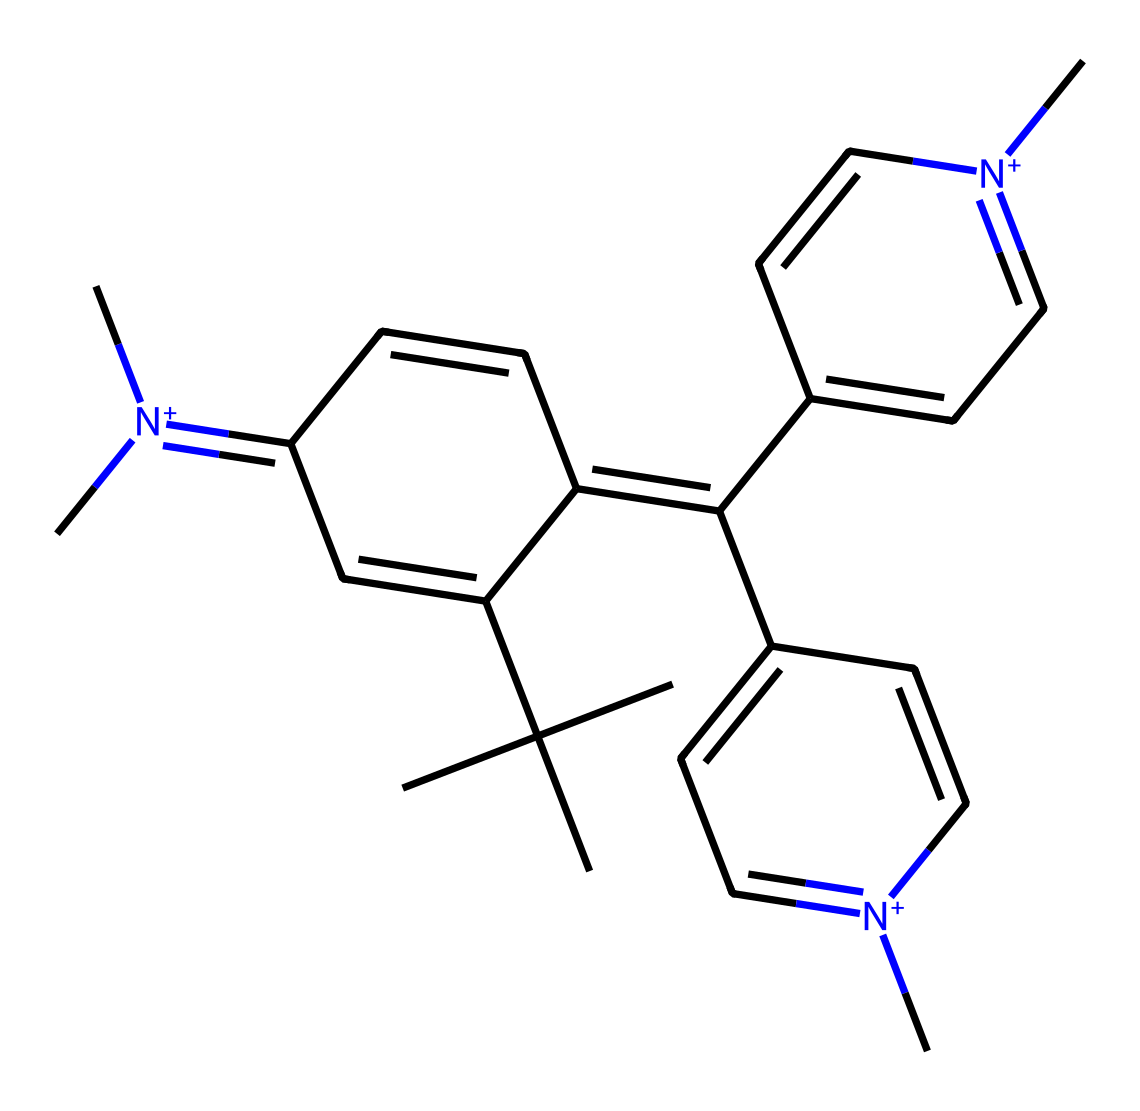What is the molecular formula of crystal violet? To determine the molecular formula, count the number of each type of atom in the SMILES representation. From the structure, we can identify 25 carbon (C) atoms, 30 hydrogen (H) atoms, and 3 nitrogen (N) atoms. Thus, the molecular formula is C25H30N3.
Answer: C25H30N3 How many nitrogen atoms are present in crystal violet? By analyzing the SMILES representation, we can identify three occurrences of the nitrogen atom (N) in the structure.
Answer: 3 What type of compound is crystal violet classified as? Based on its structure, which includes multiple aromatic rings and nitrogen, crystal violet fits the category of synthetic organic dyes. Furthermore, it is specifically a cationic dye due to the presence of positively charged nitrogen atoms.
Answer: cationic dye How many aromatic rings are there in crystal violet? Inspecting the structure revealed that there are three distinct fused aromatic rings that contribute to its complex structure. Each ring contributes to the dye's color and chemical properties.
Answer: 3 What role does the positive charge on nitrogen play in crystal violet's function? The positive charge on the nitrogen atoms contributes to the dye's ability to bind to negatively charged components in the cell walls of bacteria, enhancing its antimicrobial properties. This is crucial for its role in Gram staining, where it helps differentiate between gram-positive and gram-negative bacteria.
Answer: binding to cell walls 